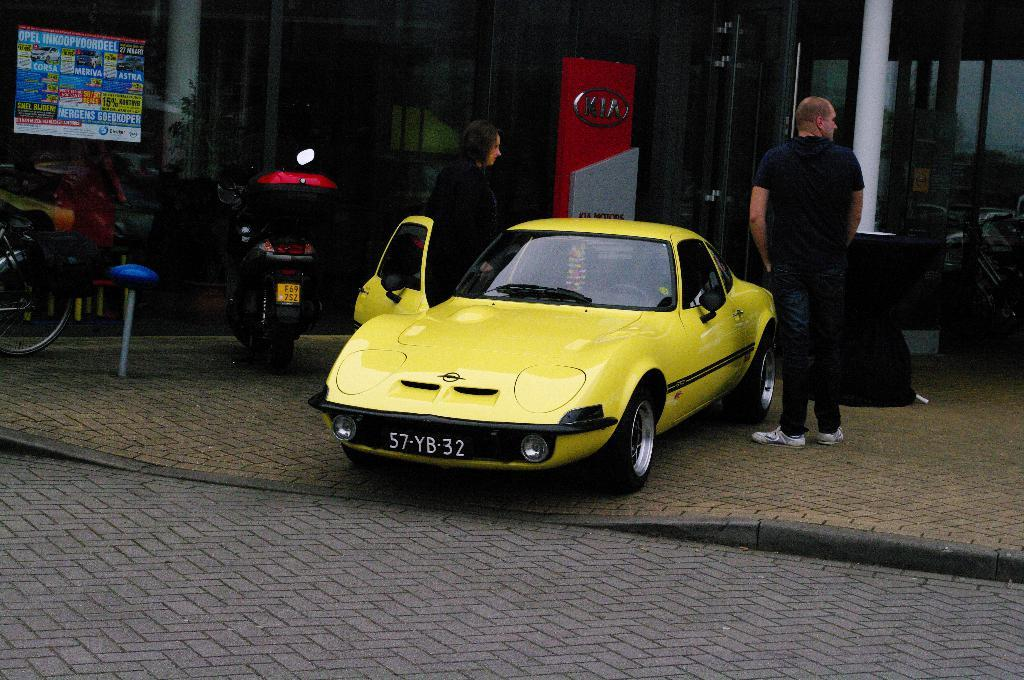<image>
Present a compact description of the photo's key features. A man is standing near a yellow sports car with the license 57-YB-32. 